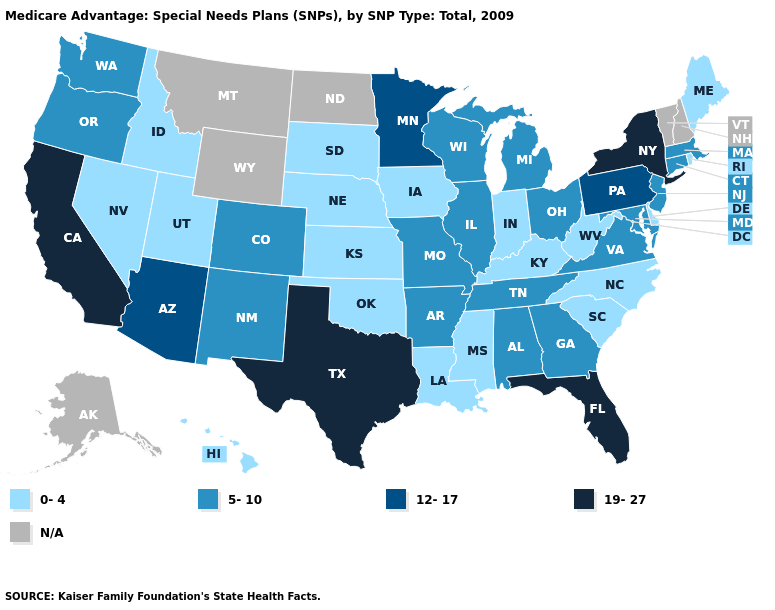Name the states that have a value in the range 19-27?
Answer briefly. California, Florida, New York, Texas. What is the lowest value in the South?
Answer briefly. 0-4. What is the value of South Dakota?
Short answer required. 0-4. Which states hav the highest value in the West?
Keep it brief. California. What is the lowest value in the Northeast?
Short answer required. 0-4. Name the states that have a value in the range 12-17?
Give a very brief answer. Arizona, Minnesota, Pennsylvania. What is the value of Minnesota?
Be succinct. 12-17. Name the states that have a value in the range 5-10?
Keep it brief. Alabama, Arkansas, Colorado, Connecticut, Georgia, Illinois, Massachusetts, Maryland, Michigan, Missouri, New Jersey, New Mexico, Ohio, Oregon, Tennessee, Virginia, Washington, Wisconsin. What is the value of South Dakota?
Keep it brief. 0-4. Name the states that have a value in the range 5-10?
Quick response, please. Alabama, Arkansas, Colorado, Connecticut, Georgia, Illinois, Massachusetts, Maryland, Michigan, Missouri, New Jersey, New Mexico, Ohio, Oregon, Tennessee, Virginia, Washington, Wisconsin. What is the value of Alabama?
Quick response, please. 5-10. How many symbols are there in the legend?
Be succinct. 5. Does California have the highest value in the West?
Quick response, please. Yes. Which states have the lowest value in the USA?
Write a very short answer. Delaware, Hawaii, Iowa, Idaho, Indiana, Kansas, Kentucky, Louisiana, Maine, Mississippi, North Carolina, Nebraska, Nevada, Oklahoma, Rhode Island, South Carolina, South Dakota, Utah, West Virginia. What is the value of Montana?
Answer briefly. N/A. 